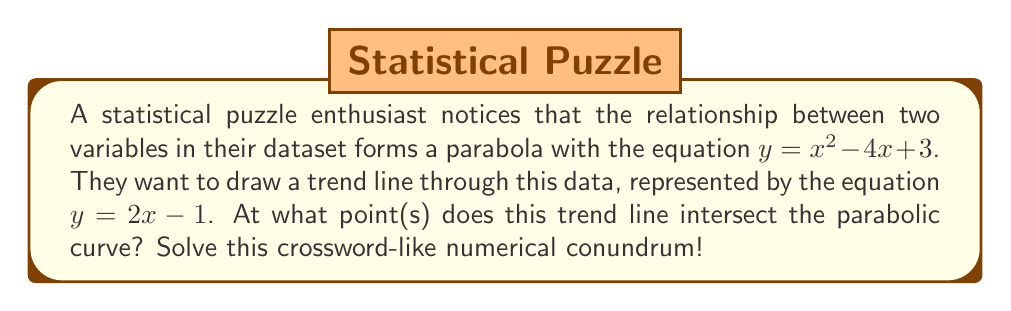Solve this math problem. Let's approach this step-by-step, like solving a crossword puzzle:

1) We need to find the point(s) where the line and parabola intersect. This occurs where their y-values are equal for the same x-value.

2) Set up an equation by setting the two y expressions equal to each other:
   $x^2 - 4x + 3 = 2x - 1$

3) Rearrange the equation to standard form:
   $x^2 - 6x + 4 = 0$

4) This is a quadratic equation. We can solve it using the quadratic formula:
   $x = \frac{-b \pm \sqrt{b^2 - 4ac}}{2a}$

   Where $a = 1$, $b = -6$, and $c = 4$

5) Plugging these values into the quadratic formula:
   $x = \frac{6 \pm \sqrt{36 - 16}}{2} = \frac{6 \pm \sqrt{20}}{2} = \frac{6 \pm 2\sqrt{5}}{2}$

6) Simplify:
   $x = 3 \pm \sqrt{5}$

7) So, we have two x-coordinates:
   $x_1 = 3 + \sqrt{5}$ and $x_2 = 3 - \sqrt{5}$

8) To find the y-coordinates, we can plug these x-values into either of the original equations. Let's use the line equation $y = 2x - 1$:

   For $x_1$: $y_1 = 2(3 + \sqrt{5}) - 1 = 5 + 2\sqrt{5}$
   For $x_2$: $y_2 = 2(3 - \sqrt{5}) - 1 = 5 - 2\sqrt{5}$

Therefore, the intersection points are $(3 + \sqrt{5}, 5 + 2\sqrt{5})$ and $(3 - \sqrt{5}, 5 - 2\sqrt{5})$.
Answer: The line intersects the parabola at two points: $(3 + \sqrt{5}, 5 + 2\sqrt{5})$ and $(3 - \sqrt{5}, 5 - 2\sqrt{5})$. 